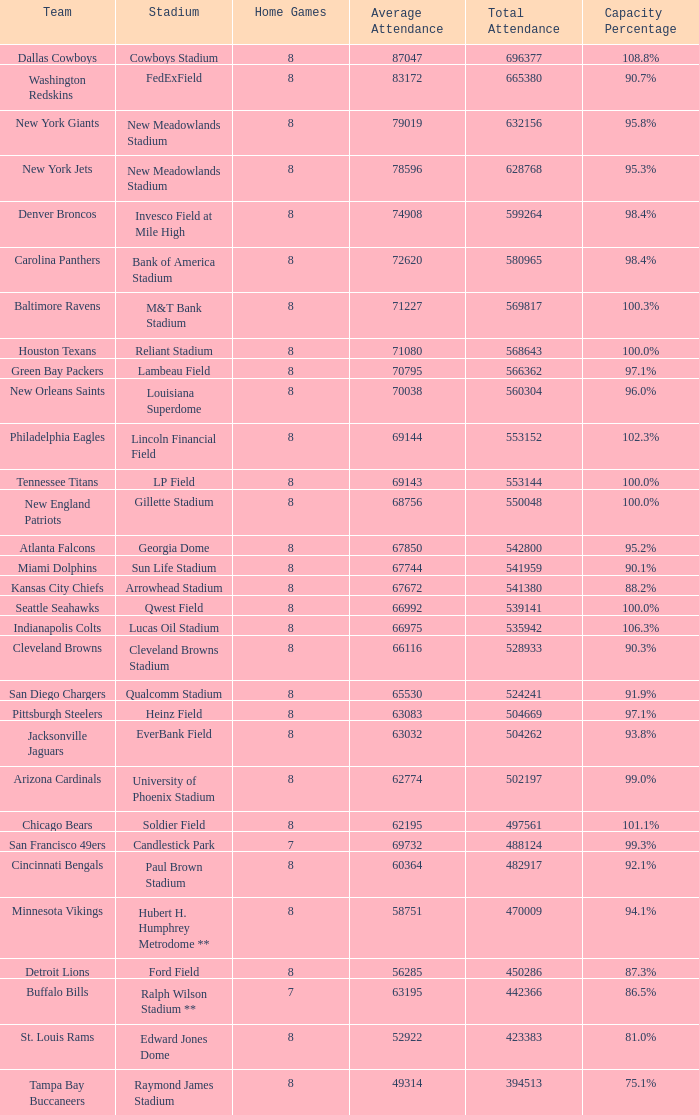What was the capacity percentage when attendance was 71080? 100.0%. 